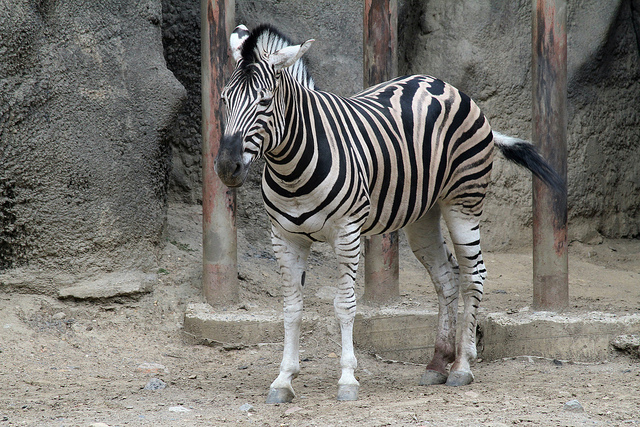Can you describe the habitat suitable for this type of zebra? Plains zebras are typically found in the grasslands and savanna woodlands of eastern and southern Africa. They thrive in environments that offer plentiful water sources and extensive grazing areas. Is that similar to the environment it is in now? Based on the image, the zebra is in a more constrained and artificial setting, likely a man-made enclosure, which differs significantly from the spacious grassy plains of its natural habitat. 